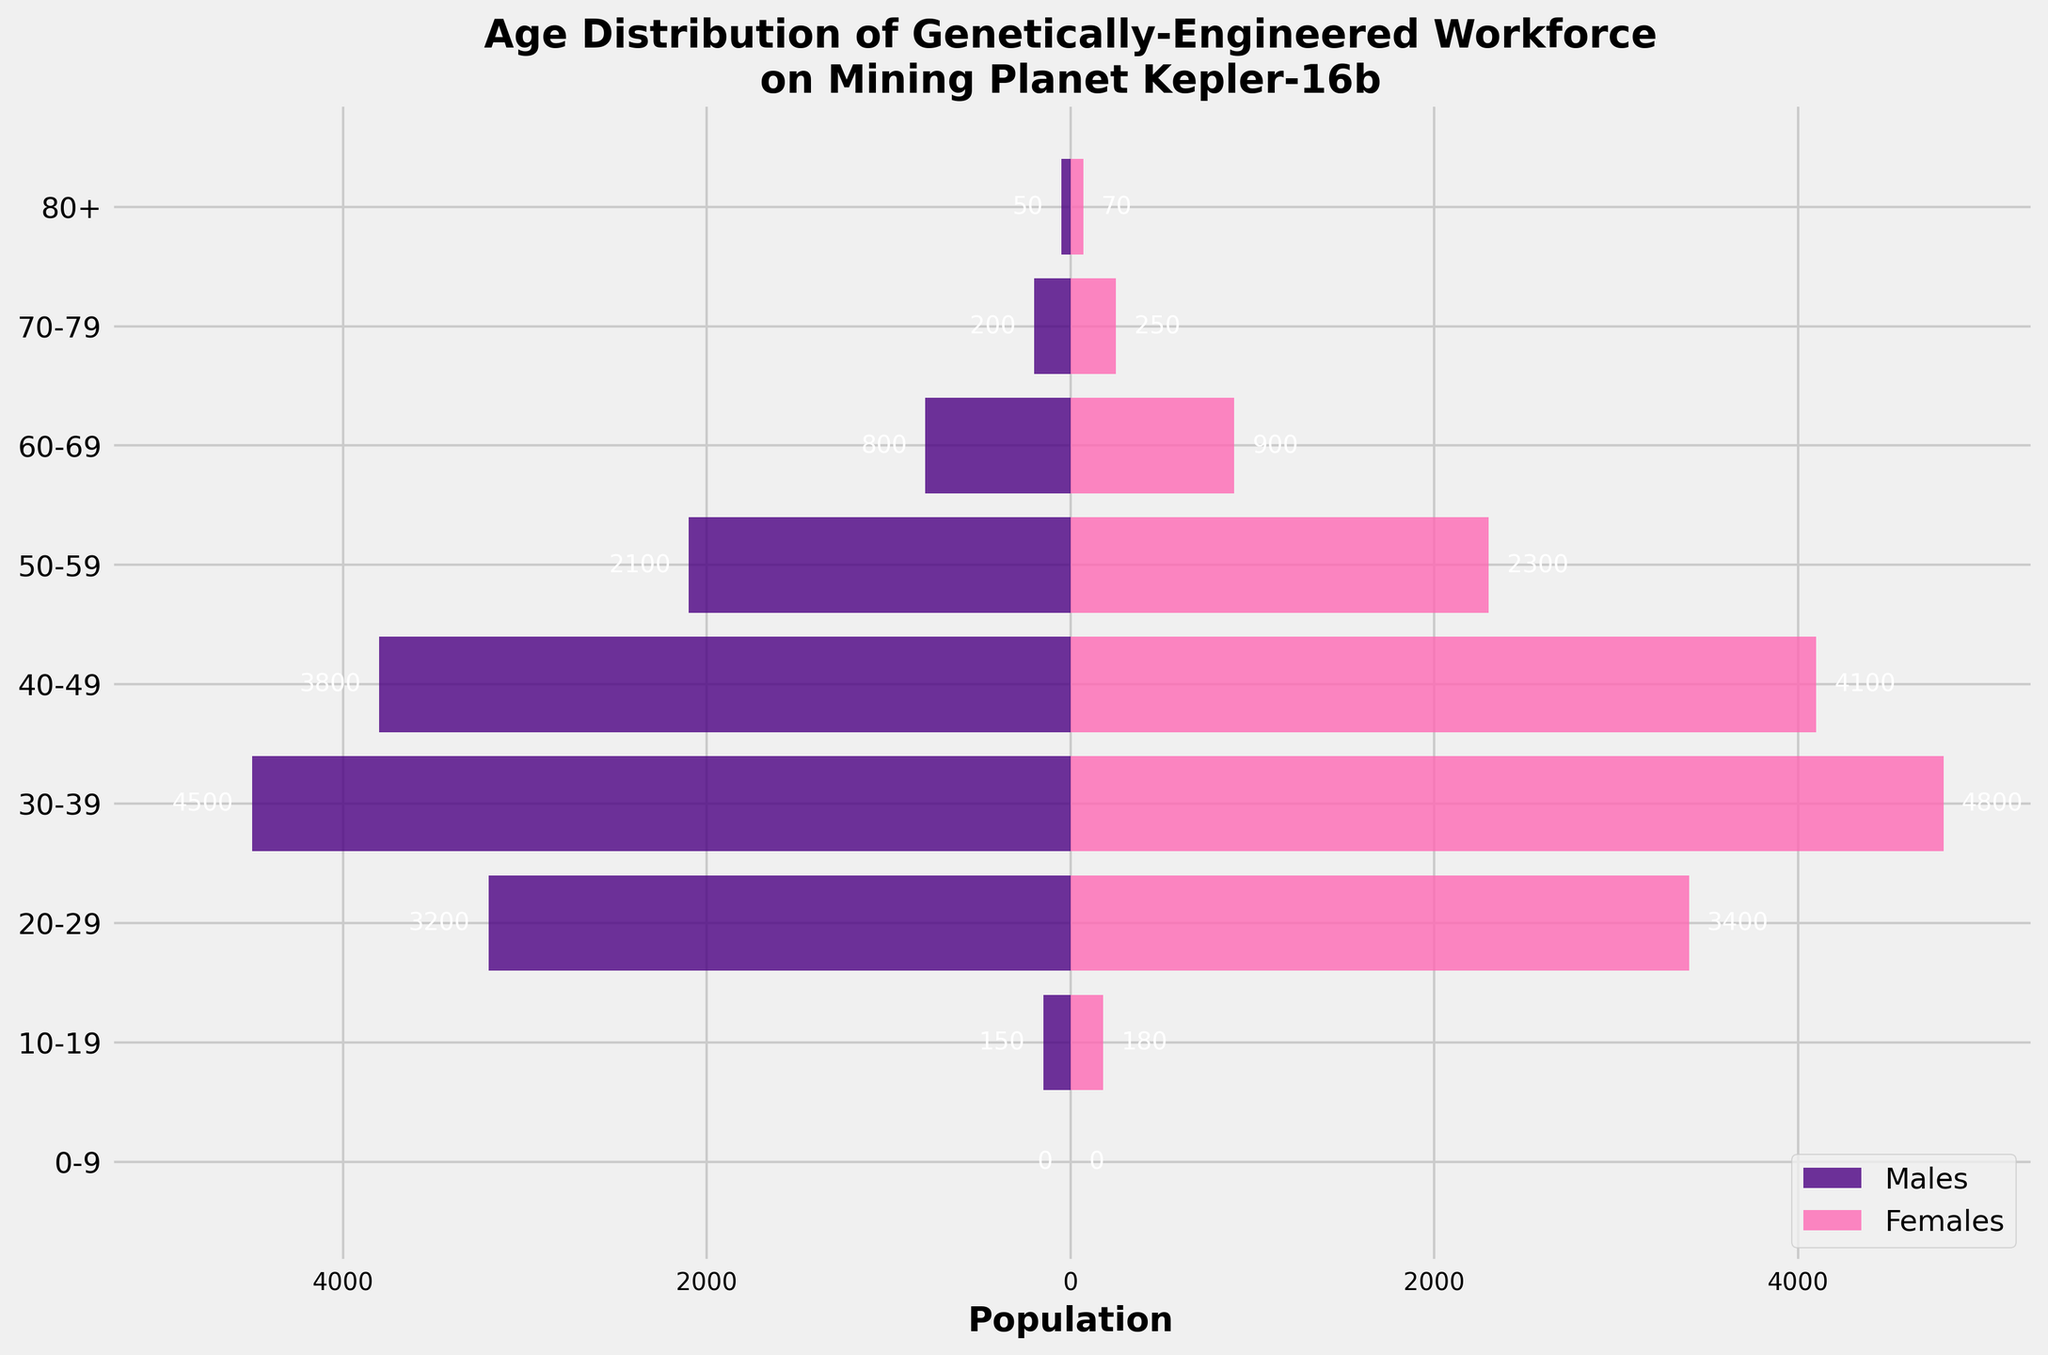What is the age group with the highest population of males? Look at the bar lengths on the left side of the population pyramid. The age group 30-39 has the longest bar for males, indicating the highest population.
Answer: 30-39 How many females are there in the age group 40-49? Check the bar length for females in the age group 40-49. The bar shows a value of 4100.
Answer: 4100 What is the total population of the age group 50-59? Sum the number of males and females in the age group 50-59. The values are 2100 males + 2300 females = 4400.
Answer: 4400 Which age group has more males than females? Compare the lengths of the bars for males and females in each age group. Both the age groups 60-69 and 70-79 have more males than females.
Answer: 60-69, 70-79 What is the age group with the smallest female population? Look for the shortest bar on the right side that represents the female population. The smallest female population is in the age group 0-9, which has no females.
Answer: 0-9 What is the approximate difference in the male population between the age groups 20-29 and 60-69? Subtract the population of males in 60-69 from the population of males in 20-29. The values are 3200 - 800 = 2400.
Answer: 2400 What percentage of the total population does the age group 30-39 constitute? First, find the total population by summing all age groups for both males and females. Then, sum the population for age group 30-39. Finally, divide the population of 30-39 by the total population and multiply by 100.
Total population = (150+3200+4500+3800+2100+800+200+50) + (180+3400+4800+4100+2300+900+250+70) = 29480.
Population of 30-39 = 4500 + 4800 = 9300.
Percentage = (9300 / 29480) * 100 ≈ 31.54%.
Answer: 31.54% How does the population of the age group 10-19 compare to that of 80+? Compare the sum of the population of males and females in the age group 10-19 with that of 80+. 10-19 has a population of 150 males + 180 females = 330. 80+ has a population of 50 males + 70 females = 120. Thus, 10-19 has a higher population.
Answer: 10-19 Are there any age groups with an equal number of males and females? Check if any age group has identical bar lengths for both males and females. There are no age groups with an equal number of males and females.
Answer: No Which age groups have more females than males, and by how much? Compare the lengths of the bars for males and females in each age group. The age groups 10-19, 20-29, 30-39, 40-49, 50-59, and 80+ have more females than males. Calculate the difference: 
10-19: (180 - 150) = 30, 
20-29: (3400 - 3200) = 200, 
30-39: (4800 - 4500) = 300, 
40-49: (4100 - 3800) = 300, 
50-59: (2300 - 2100) = 200, 
80+: (70 - 50) = 20.
Answer: 10-19: 30, 20-29: 200, 30-39: 300, 40-49: 300, 50-59: 200, 80+: 20 